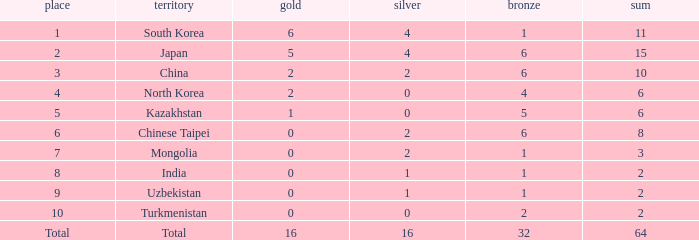What is the total Gold's less than 0? 0.0. Would you mind parsing the complete table? {'header': ['place', 'territory', 'gold', 'silver', 'bronze', 'sum'], 'rows': [['1', 'South Korea', '6', '4', '1', '11'], ['2', 'Japan', '5', '4', '6', '15'], ['3', 'China', '2', '2', '6', '10'], ['4', 'North Korea', '2', '0', '4', '6'], ['5', 'Kazakhstan', '1', '0', '5', '6'], ['6', 'Chinese Taipei', '0', '2', '6', '8'], ['7', 'Mongolia', '0', '2', '1', '3'], ['8', 'India', '0', '1', '1', '2'], ['9', 'Uzbekistan', '0', '1', '1', '2'], ['10', 'Turkmenistan', '0', '0', '2', '2'], ['Total', 'Total', '16', '16', '32', '64']]} 